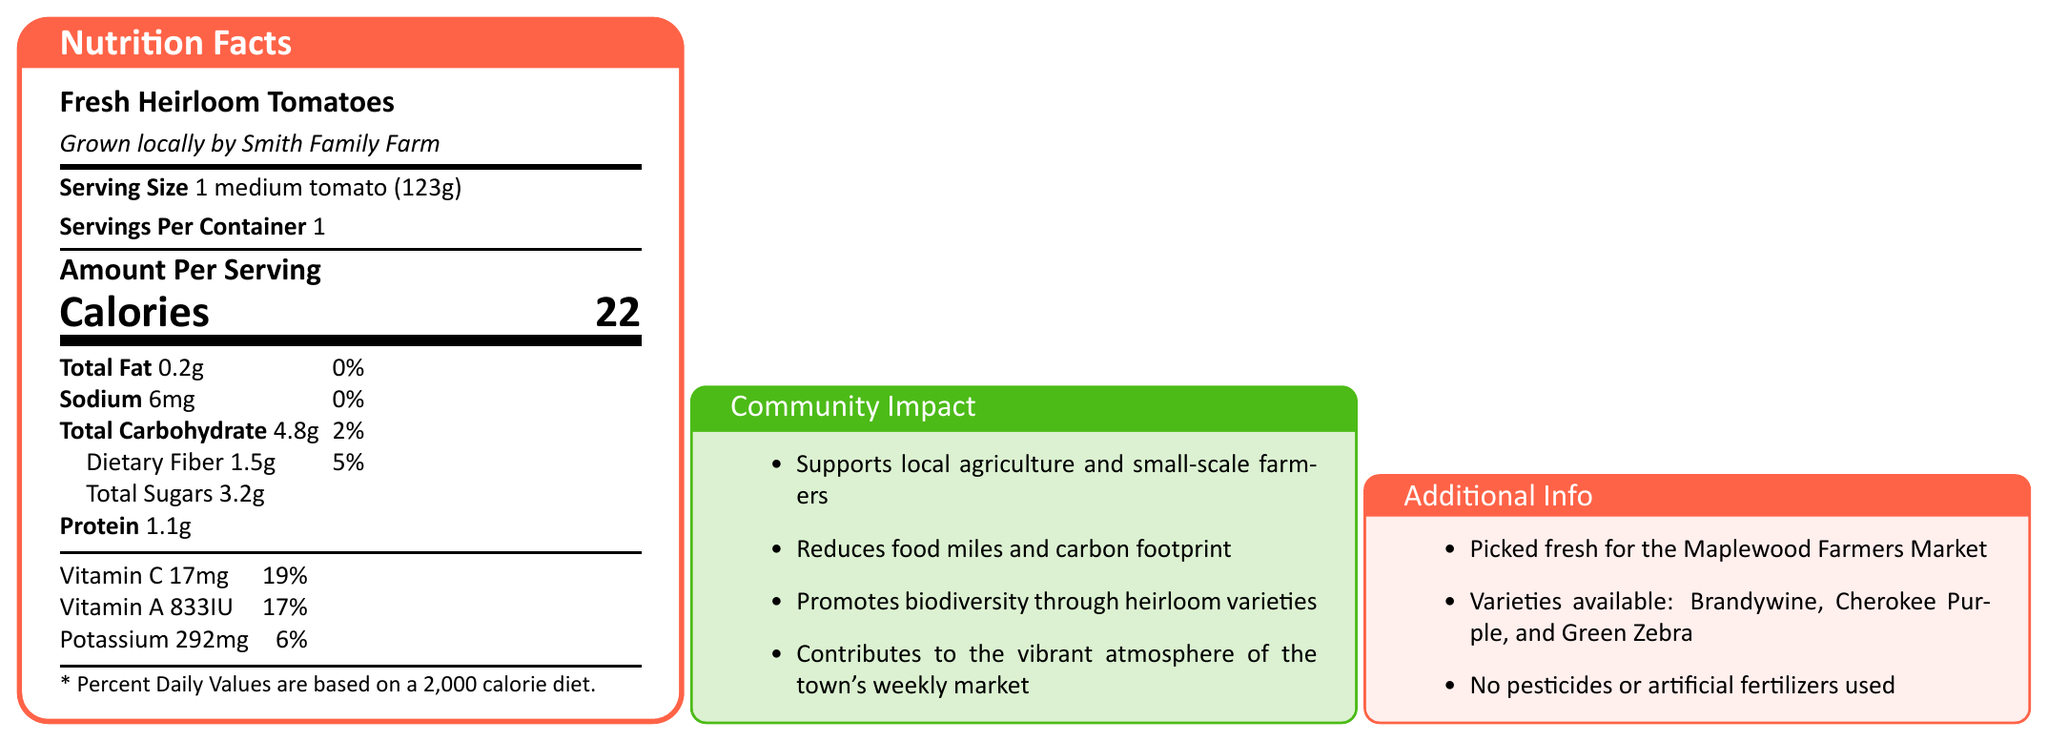what is the serving size for Fresh Heirloom Tomatoes? The serving size is clearly stated in the document as "1 medium tomato (123g)".
Answer: 1 medium tomato (123g) What is the calorie content per serving? The document lists the calorie content as "Calories 22" under the "Amount Per Serving" section.
Answer: 22 Calories How much total fat is in one medium tomato? According to the nutrition facts, the total fat content per serving is "0.2g".
Answer: 0.2g How much dietary fiber does one serving provide? The nutritional information specifies "Dietary Fiber 1.5g".
Answer: 1.5g Which farm grows the Fresh Heirloom Tomatoes sold at the market? In the "Additional Info" section, it is mentioned that these tomatoes are "Grown locally by Smith Family Farm".
Answer: Smith Family Farm How much Potassium is in each serving? The document states that there are "Potassium 292mg" in each serving.
Answer: 292mg What percentage of the daily value of Vitamin C is provided by one serving? The nutritional information shows "Vitamin C 17mg" which is "19%" of the daily value.
Answer: 19% True or False: The tomatoes contain no added sugars. There is no indication of added sugars; the document simply lists "Total Sugars" as 3.2g without specifying added sugars.
Answer: True What varieties of heirloom tomatoes are available? A. Brandywine B. Cherokee Purple C. Green Zebra D. All of the Above The additional info section lists all these varieties: Brandywine, Cherokee Purple, and Green Zebra.
Answer: D What is one community impact of purchasing these tomatoes? A. Increases global trade B. Supports local agriculture C. Promotes import economies The document lists "Supports local agriculture and small-scale farmers" as a community impact.
Answer: B Can the total amount of sugars in the tomatoes be determined from the document? The document lists "Total Sugars" as 3.2g per serving.
Answer: Yes Are any artificial fertilizers used to grow these tomatoes? The "Additional Info" section states that "No pesticides or artificial fertilizers used."
Answer: No Which of the following is NOT an impact listed in the Community Impact section? A. Promotes biodiversity B. Supports industrial farming C. Reduces food miles The community impact section lists "Supports local agriculture and small-scale farmers," "Reduces food miles and carbon footprint," etc. It does not mention industrial farming.
Answer: B Summarize the document in one sentence. The main content of the document includes nutrition facts, additional information about the product's origin and farming practices, and the benefits to the local community.
Answer: The document provides nutritional information for Fresh Heirloom Tomatoes, details about their local cultivation and varieties, and discusses the positive community impact of buying them. How much sodium is present in one serving? The nutritional information indicates that there are 6mg of sodium per serving.
Answer: 6mg What does the "percent daily value" indicate and how is it calculated? The document states that percent daily values are based on a 2,000 calorie diet, but it does not explain how the specific percentages are calculated.
Answer: Cannot be determined 